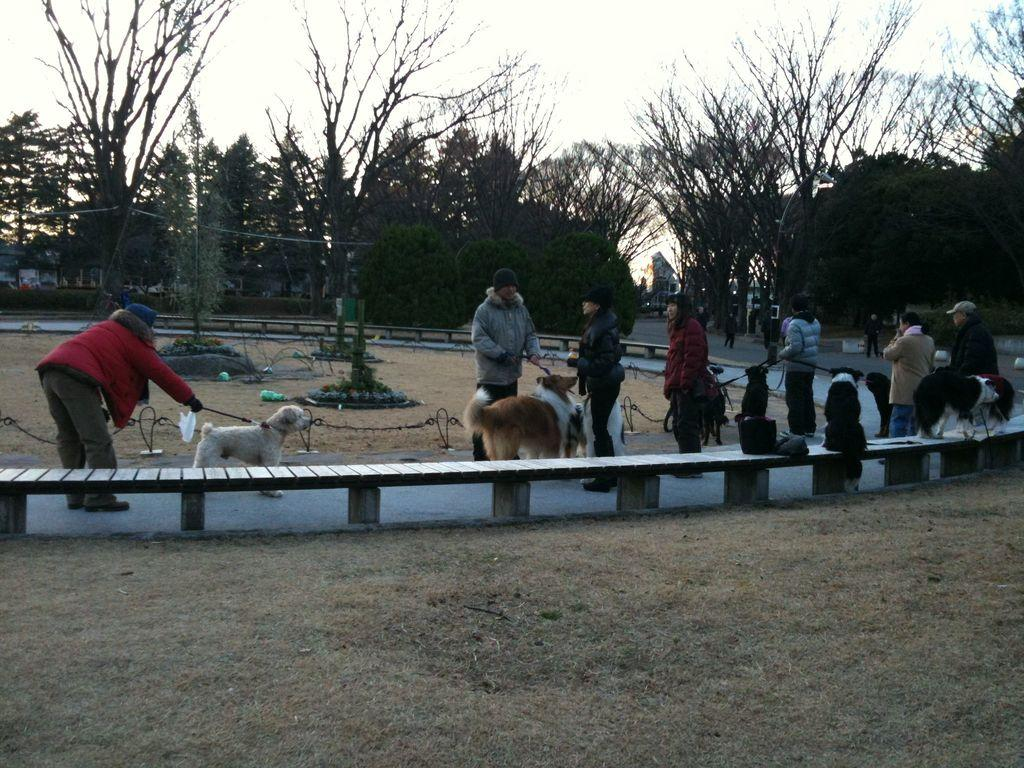What are the people in the image doing? The people in the image are standing on the ground and holding dogs. What object can be seen in the image that people might sit on? There is a bench in the image. What type of natural scenery is visible in the background of the image? There are trees visible in the background of the image. What type of chalk is being used to draw on the ground in the image? There is no chalk present in the image, and no one is drawing on the ground. 